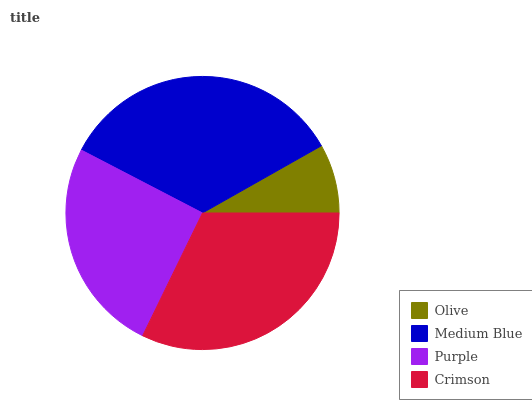Is Olive the minimum?
Answer yes or no. Yes. Is Medium Blue the maximum?
Answer yes or no. Yes. Is Purple the minimum?
Answer yes or no. No. Is Purple the maximum?
Answer yes or no. No. Is Medium Blue greater than Purple?
Answer yes or no. Yes. Is Purple less than Medium Blue?
Answer yes or no. Yes. Is Purple greater than Medium Blue?
Answer yes or no. No. Is Medium Blue less than Purple?
Answer yes or no. No. Is Crimson the high median?
Answer yes or no. Yes. Is Purple the low median?
Answer yes or no. Yes. Is Olive the high median?
Answer yes or no. No. Is Crimson the low median?
Answer yes or no. No. 